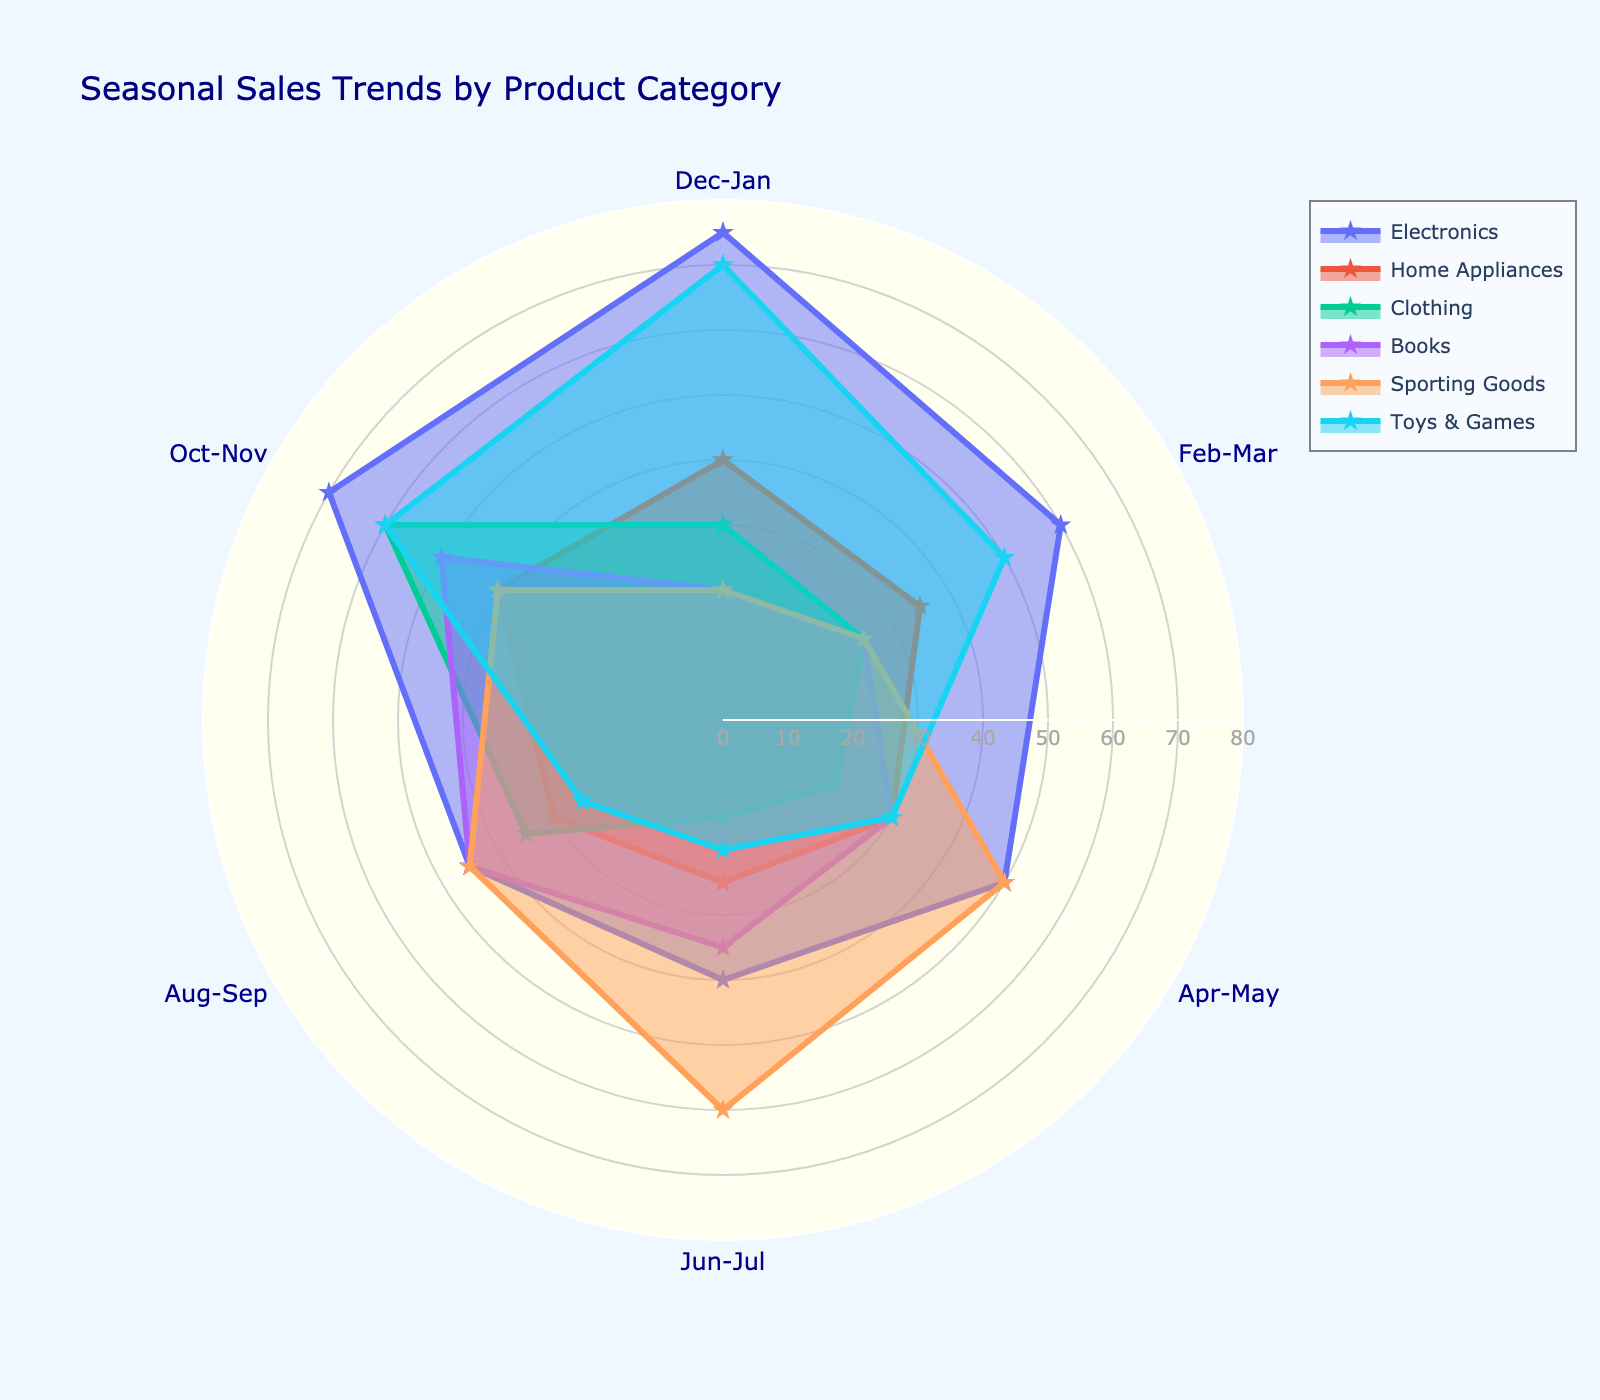What is the title of the figure? The title of the figure is typically located at the top center. In this case, it reads 'Seasonal Sales Trends by Product Category'.
Answer: Seasonal Sales Trends by Product Category Which category has the highest sales in Dec-Jan? By looking at the radial plot, you can see that the 'Electronics' category reaches the highest point in the Dec-Jan segment, which is 75.
Answer: Electronics How do sales of 'Clothing' in Oct-Nov compare to those in Jun-Jul? In the chart, you see that 'Clothing' has a higher value in Oct-Nov (60) compared to Jun-Jul (15).
Answer: Oct-Nov is higher Which product category has the most consistent sales across all seasons? Consistent sales mean the values do not vary much across seasons. By examining the radar chart, 'Home Appliances' shows the least fluctuation with values ranging closely around 30-40.
Answer: Home Appliances What is the combined sales value for 'Toys & Games' in Apr-May and Jun-Jul? To address this, look at the values in the Apr-May and Jun-Jul segments for 'Toys & Games' (30 and 20). Adding these together gives 30 + 20 = 50.
Answer: 50 Which product category shows a peak in sales in Aug-Sep? Look for the highest point in the Aug-Sep section. 'Sporting Goods' peaks in this period with a value of 60.
Answer: Sporting Goods Rank the categories by their sales trends in Oct-Nov from highest to lowest. By comparing the segments for Oct-Nov, the ranked categories are: Electronics (70), Clothing (60), Books (50), Toys & Games (60), Sporting Goods (40), and Home Appliances (40).
Answer: Electronics, Clothing, Books, Toys & Games, Sporting Goods, Home Appliances What is the average sales value of 'Books' over the entire year? To find the average, add the values for 'Books' across all segments (20 + 25 + 30 + 35 + 45 + 50) = 205 and divide by the number of seasons (6). The average is 205 / 6 ≈ 34.17.
Answer: 34.17 Which category has the highest rise in sales from Jun-Jul to Oct-Nov? To find the answer, calculate the difference between the two periods for each category. 'Electronics' rises from 40 to 70, giving a difference of 30, which is the highest increase.
Answer: Electronics How do the sales trends for 'Sporting Goods' and 'Toys & Games' differ throughout the year? Comparing their sales across all segments, 'Sporting Goods' starts lower and peaks in Aug-Sep (60) then declines, while 'Toys & Games' have two peaks, one early in Dec-Jan (70) and one late in Oct-Nov (60), showing more fluctuation.
Answer: Sporting Goods peaks mid-year, Toys & Games have early and late peaks 